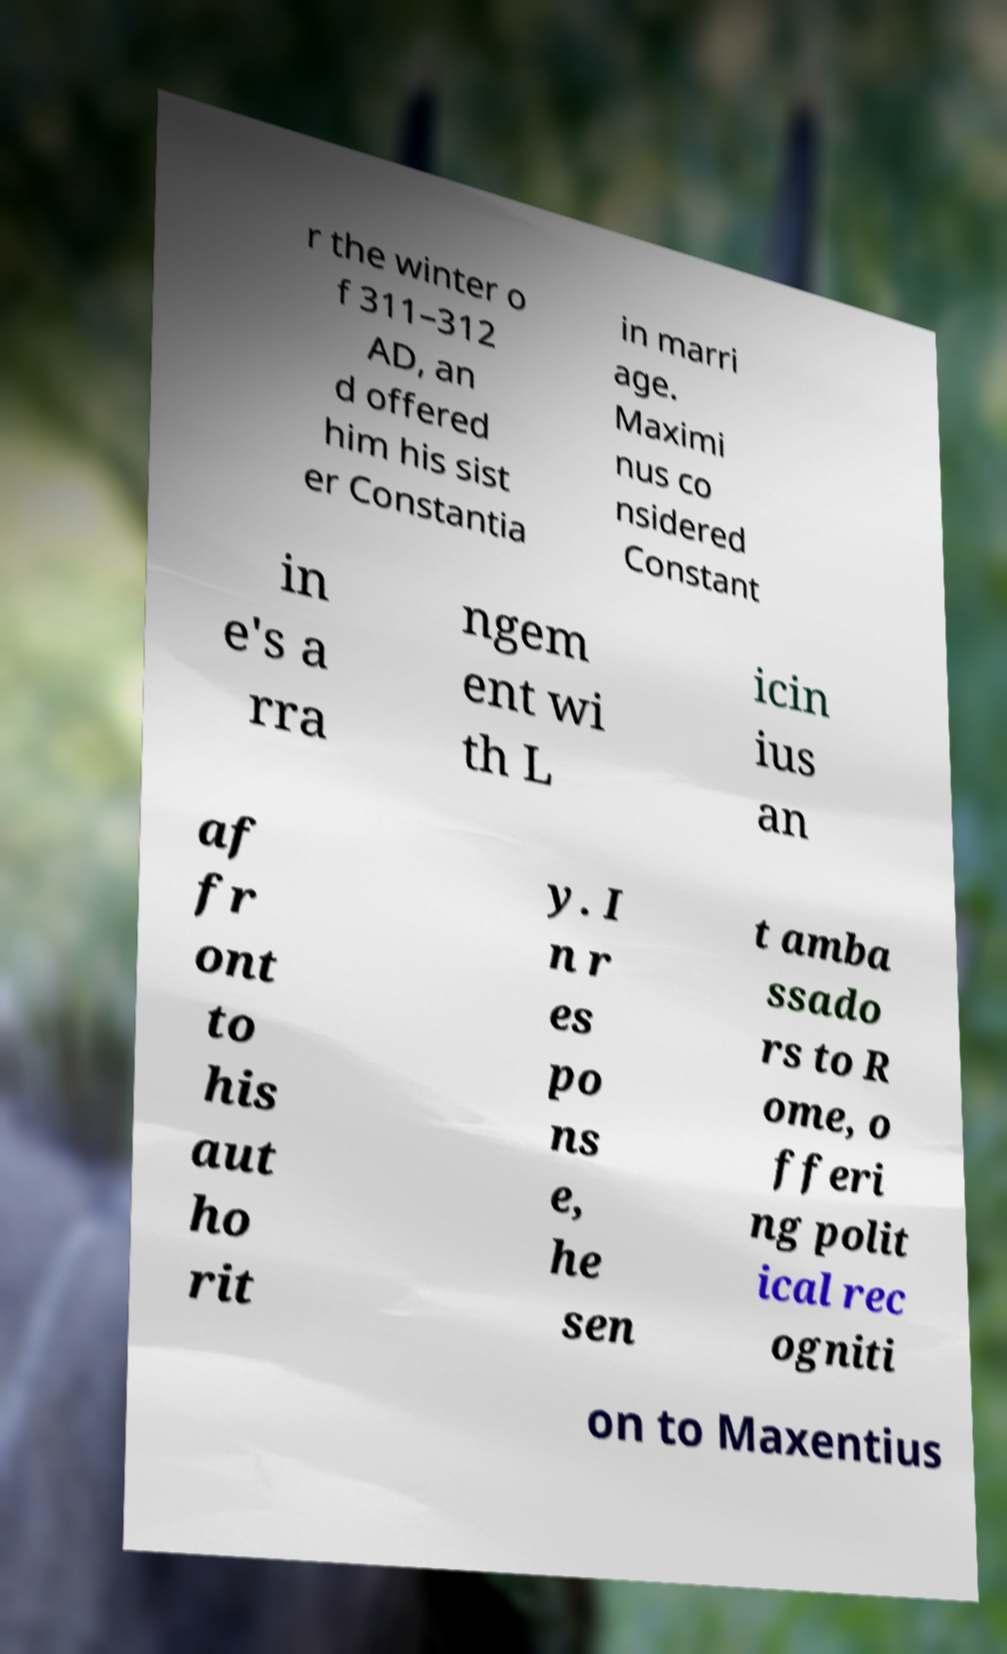There's text embedded in this image that I need extracted. Can you transcribe it verbatim? r the winter o f 311–312 AD, an d offered him his sist er Constantia in marri age. Maximi nus co nsidered Constant in e's a rra ngem ent wi th L icin ius an af fr ont to his aut ho rit y. I n r es po ns e, he sen t amba ssado rs to R ome, o fferi ng polit ical rec ogniti on to Maxentius 